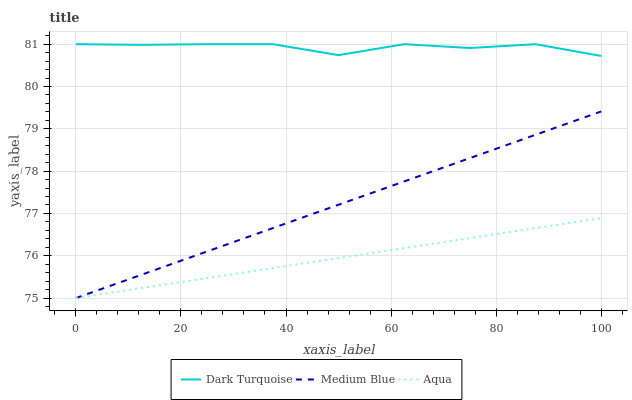Does Aqua have the minimum area under the curve?
Answer yes or no. Yes. Does Dark Turquoise have the maximum area under the curve?
Answer yes or no. Yes. Does Medium Blue have the minimum area under the curve?
Answer yes or no. No. Does Medium Blue have the maximum area under the curve?
Answer yes or no. No. Is Medium Blue the smoothest?
Answer yes or no. Yes. Is Dark Turquoise the roughest?
Answer yes or no. Yes. Is Dark Turquoise the smoothest?
Answer yes or no. No. Is Medium Blue the roughest?
Answer yes or no. No. Does Aqua have the lowest value?
Answer yes or no. Yes. Does Dark Turquoise have the lowest value?
Answer yes or no. No. Does Dark Turquoise have the highest value?
Answer yes or no. Yes. Does Medium Blue have the highest value?
Answer yes or no. No. Is Medium Blue less than Dark Turquoise?
Answer yes or no. Yes. Is Dark Turquoise greater than Medium Blue?
Answer yes or no. Yes. Does Medium Blue intersect Aqua?
Answer yes or no. Yes. Is Medium Blue less than Aqua?
Answer yes or no. No. Is Medium Blue greater than Aqua?
Answer yes or no. No. Does Medium Blue intersect Dark Turquoise?
Answer yes or no. No. 